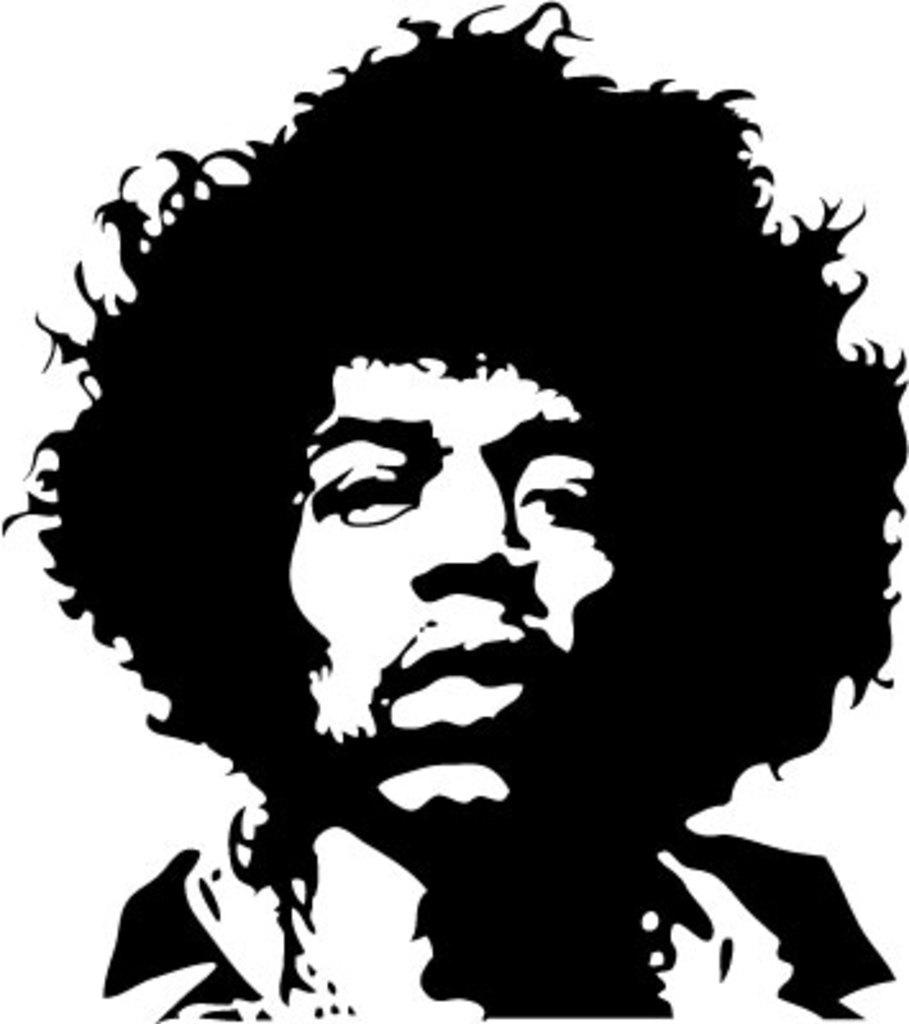What type of image is present in the picture? There is a black and white photo in the image. What is depicted in the photo? The photo contains an image of a man. What type of toy can be seen next to the man in the image? There is no toy present in the image; it only contains a black and white photo of a man. 